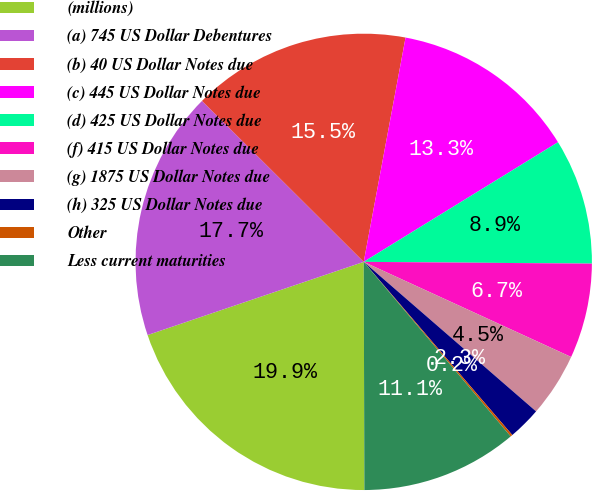Convert chart. <chart><loc_0><loc_0><loc_500><loc_500><pie_chart><fcel>(millions)<fcel>(a) 745 US Dollar Debentures<fcel>(b) 40 US Dollar Notes due<fcel>(c) 445 US Dollar Notes due<fcel>(d) 425 US Dollar Notes due<fcel>(f) 415 US Dollar Notes due<fcel>(g) 1875 US Dollar Notes due<fcel>(h) 325 US Dollar Notes due<fcel>Other<fcel>Less current maturities<nl><fcel>19.85%<fcel>17.66%<fcel>15.47%<fcel>13.28%<fcel>8.91%<fcel>6.72%<fcel>4.53%<fcel>2.34%<fcel>0.15%<fcel>11.09%<nl></chart> 